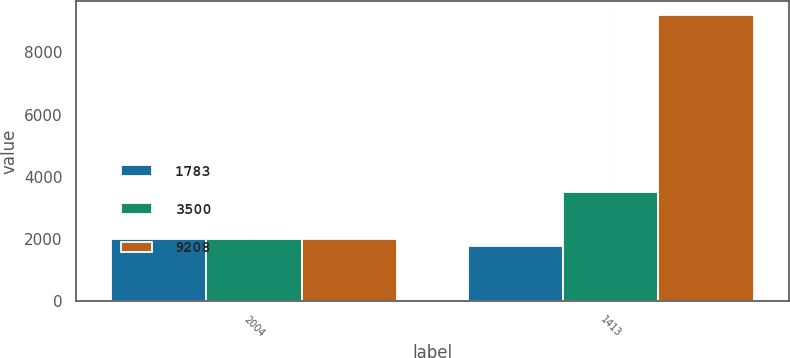<chart> <loc_0><loc_0><loc_500><loc_500><stacked_bar_chart><ecel><fcel>2004<fcel>1413<nl><fcel>1783<fcel>2003<fcel>1783<nl><fcel>3500<fcel>2002<fcel>3500<nl><fcel>9208<fcel>2001<fcel>9208<nl></chart> 